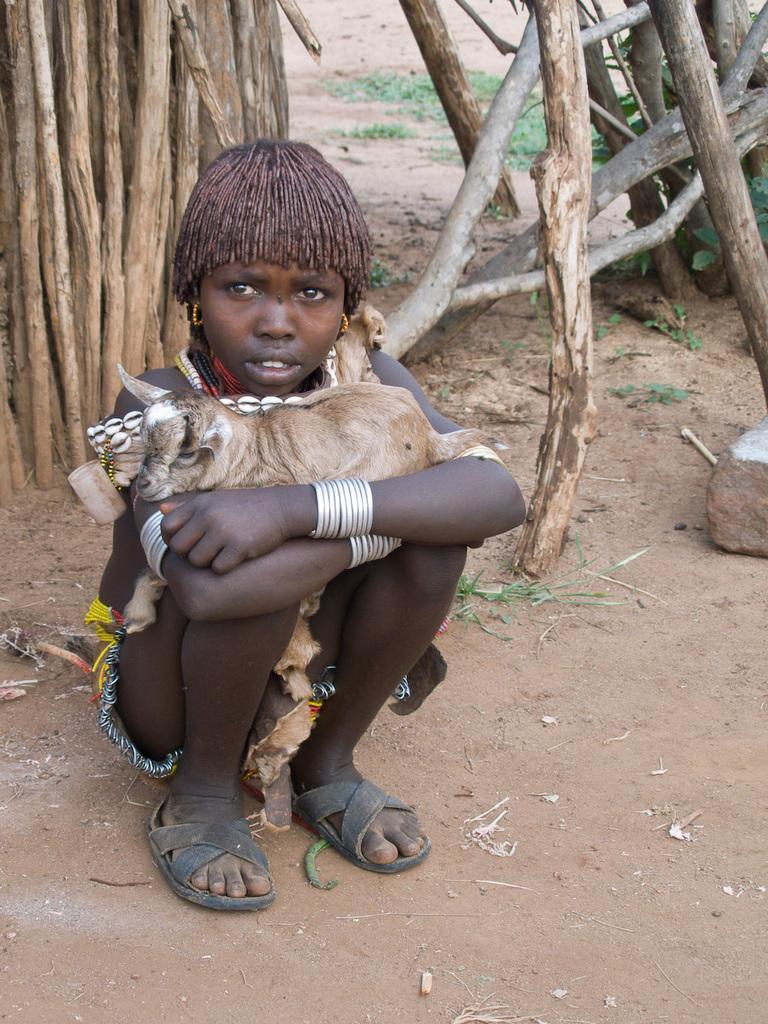In one or two sentences, can you explain what this image depicts? This image consists of sticks at the top. In the middle there is a child sitting holding an animal in the hands. 